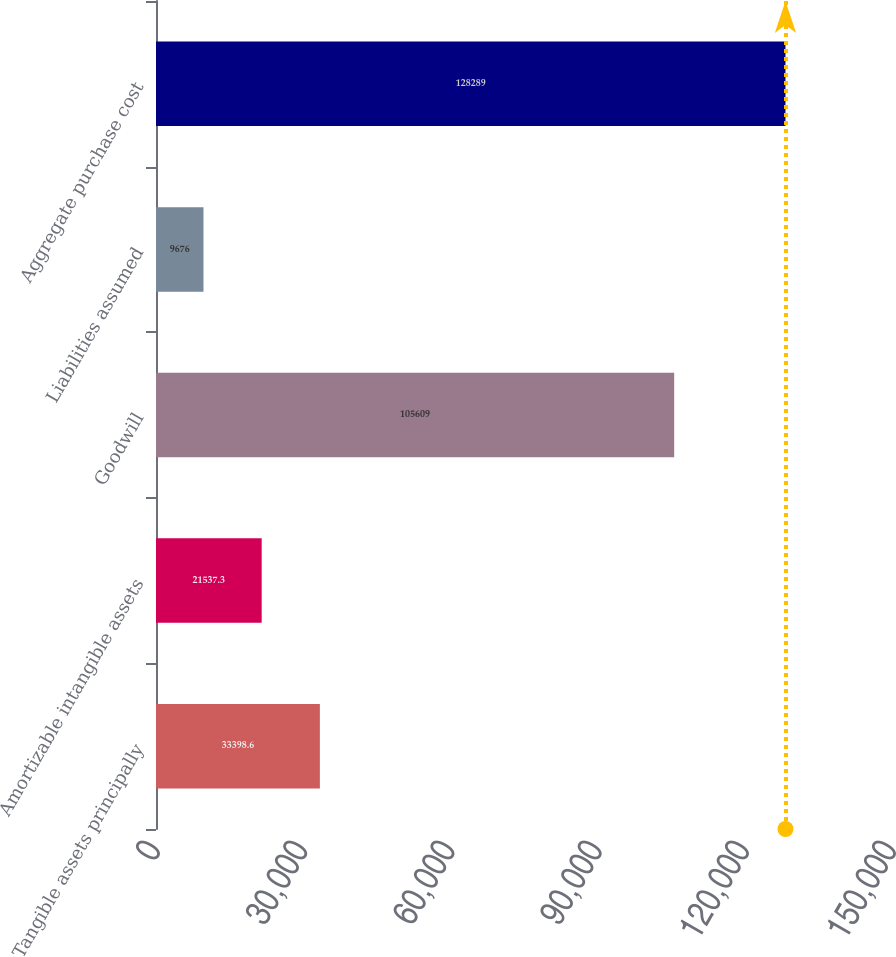<chart> <loc_0><loc_0><loc_500><loc_500><bar_chart><fcel>Tangible assets principally<fcel>Amortizable intangible assets<fcel>Goodwill<fcel>Liabilities assumed<fcel>Aggregate purchase cost<nl><fcel>33398.6<fcel>21537.3<fcel>105609<fcel>9676<fcel>128289<nl></chart> 